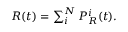Convert formula to latex. <formula><loc_0><loc_0><loc_500><loc_500>\begin{array} { r } { R ( t ) = \sum _ { i } ^ { N } { P _ { R } ^ { i } ( t ) } . } \end{array}</formula> 